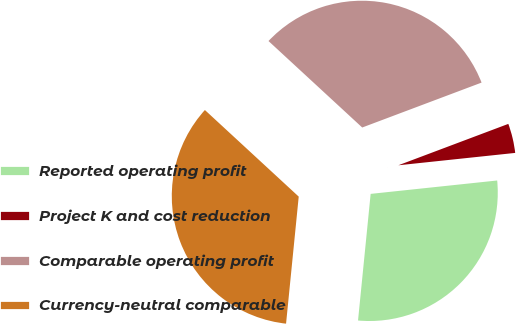Convert chart. <chart><loc_0><loc_0><loc_500><loc_500><pie_chart><fcel>Reported operating profit<fcel>Project K and cost reduction<fcel>Comparable operating profit<fcel>Currency-neutral comparable<nl><fcel>28.26%<fcel>4.05%<fcel>32.41%<fcel>35.28%<nl></chart> 